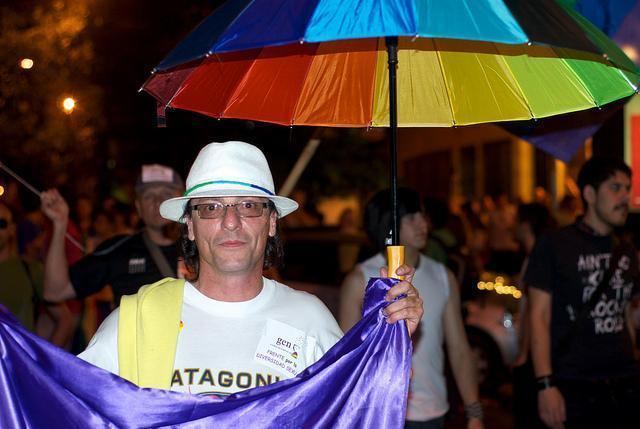How many people are in the picture?
Give a very brief answer. 7. How many cars are visible?
Give a very brief answer. 2. 